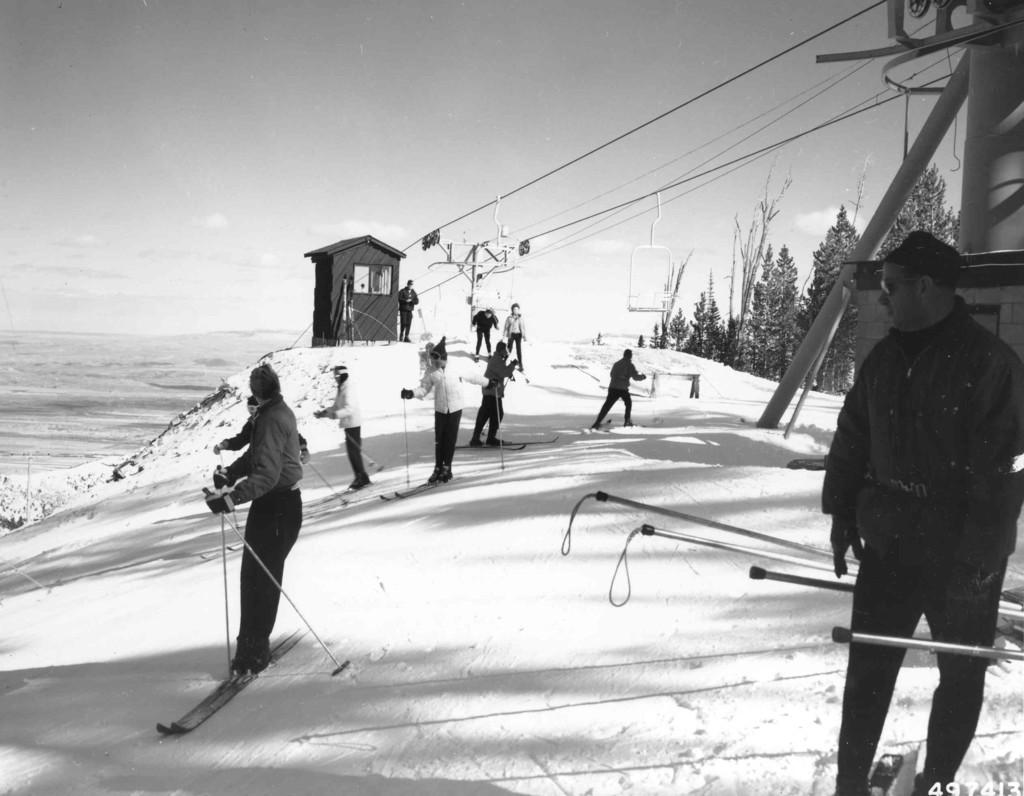Who or what can be seen in the image? There are people in the image. What are the people doing in the image? The people are trekking on snow. What type of advertisement can be seen on the desk in the image? There is no desk or advertisement present in the image; it features people trekking on snow. What type of skirt is the person wearing in the image? There is no skirt visible in the image, as the people are dressed for trekking in the snow. 